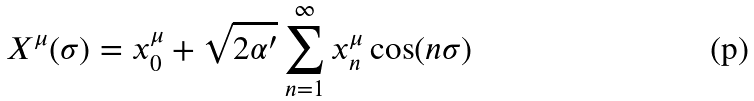<formula> <loc_0><loc_0><loc_500><loc_500>X ^ { \mu } ( \sigma ) = x _ { 0 } ^ { \mu } + \sqrt { 2 \alpha ^ { \prime } } \sum _ { n = 1 } ^ { \infty } x _ { n } ^ { \mu } \cos ( n \sigma )</formula> 